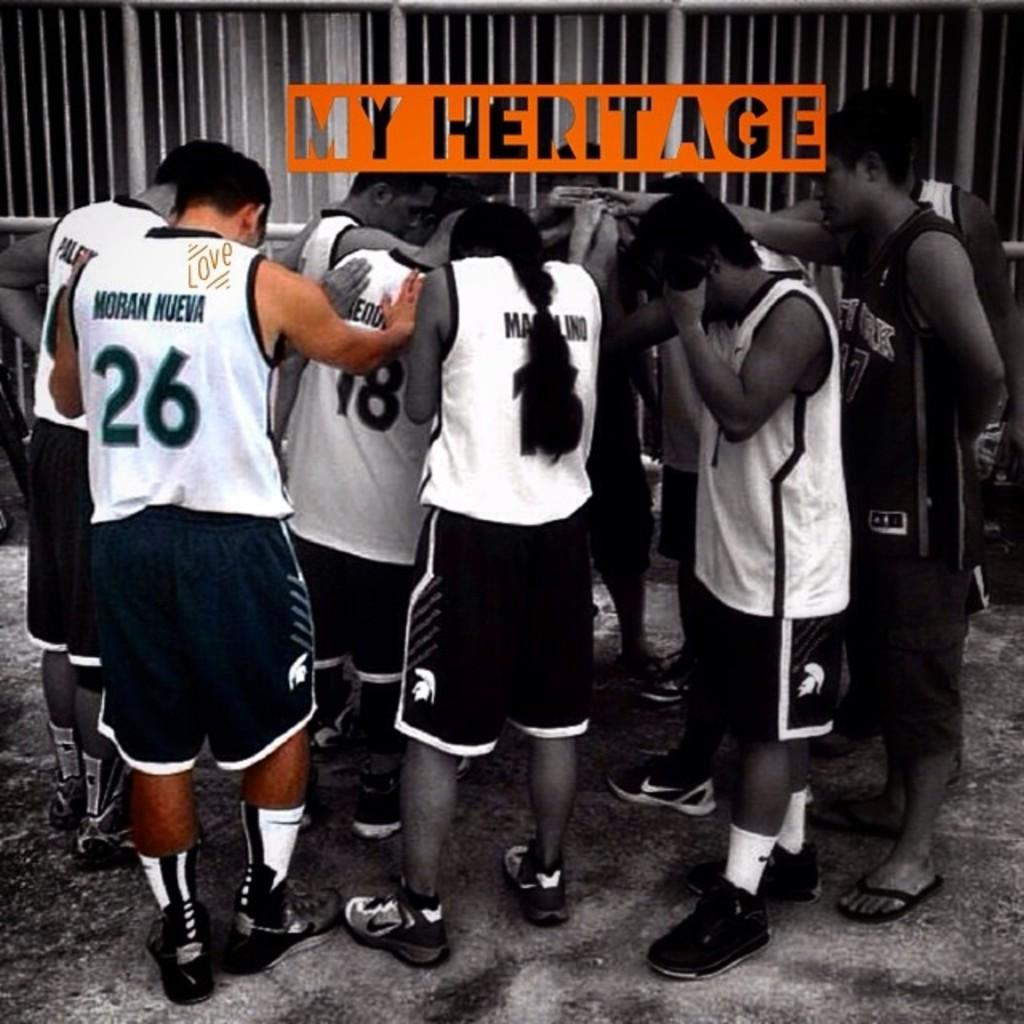<image>
Describe the image concisely. Players hid their faces, the words My Heritage appear over the image. 